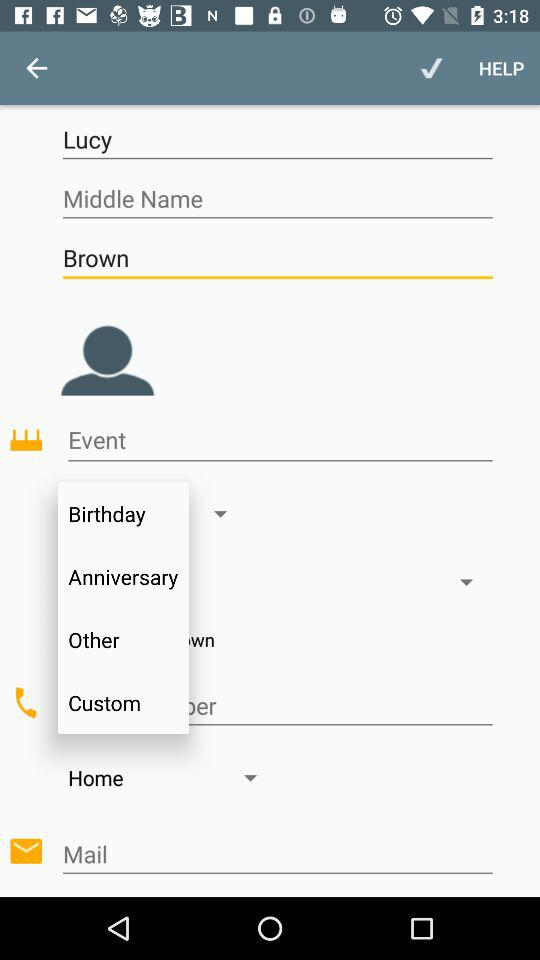What is the user's last name? The user's last name is Brown. 